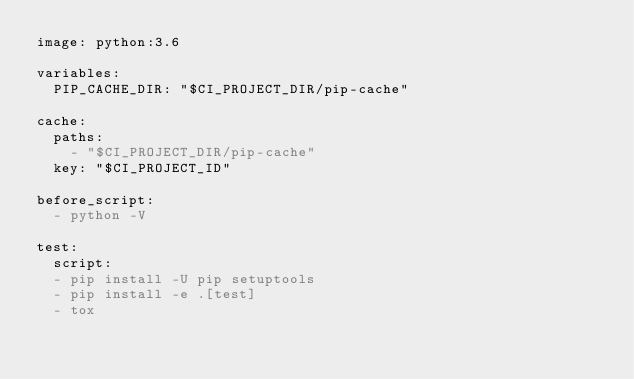Convert code to text. <code><loc_0><loc_0><loc_500><loc_500><_YAML_>image: python:3.6

variables:
  PIP_CACHE_DIR: "$CI_PROJECT_DIR/pip-cache"

cache:
  paths:
    - "$CI_PROJECT_DIR/pip-cache"
  key: "$CI_PROJECT_ID"

before_script:
  - python -V

test:
  script:
  - pip install -U pip setuptools
  - pip install -e .[test]
  - tox

</code> 